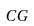<formula> <loc_0><loc_0><loc_500><loc_500>C G</formula> 